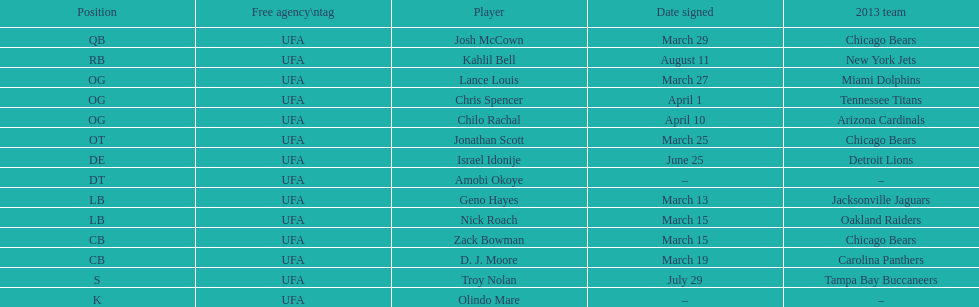Total number of players that signed in march? 7. 